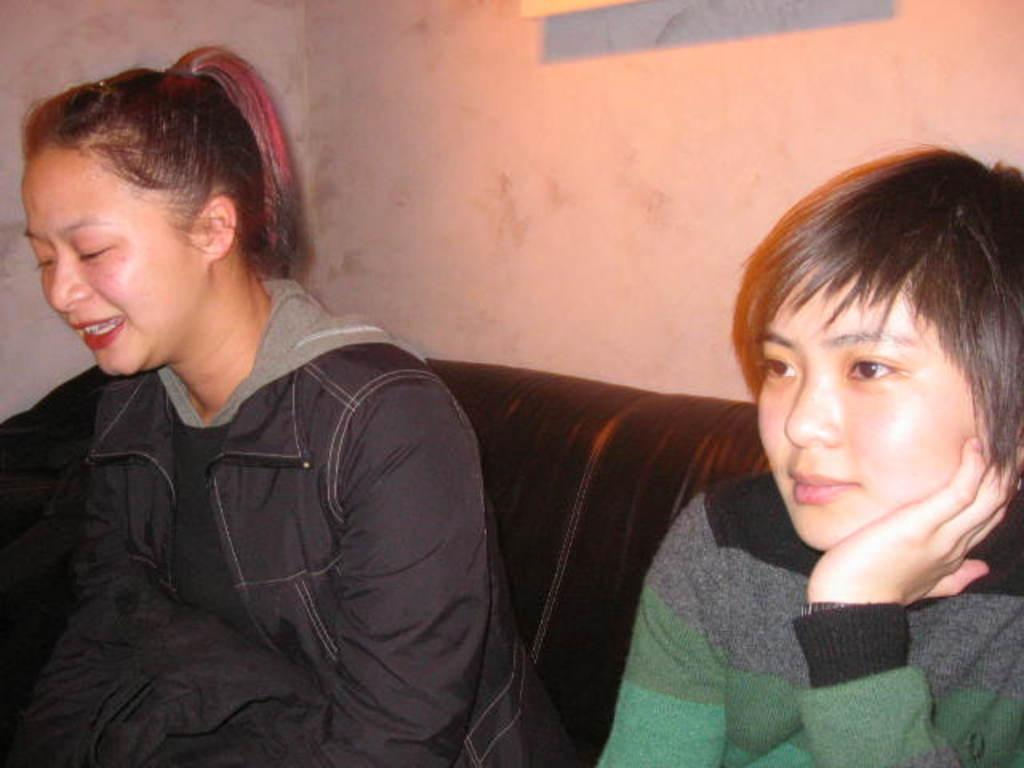How many people are in the image? There are two women in the image. What are the women doing in the image? The women are sitting on a couch. What is visible behind the women? There is a wall in the image. Can you describe the unspecified object at the top of the image? Unfortunately, the facts provided do not give enough information about the unspecified object at the top of the image. What type of music is the band playing in the background of the image? There is no band present in the image, so it is not possible to determine what type of music might be playing. 